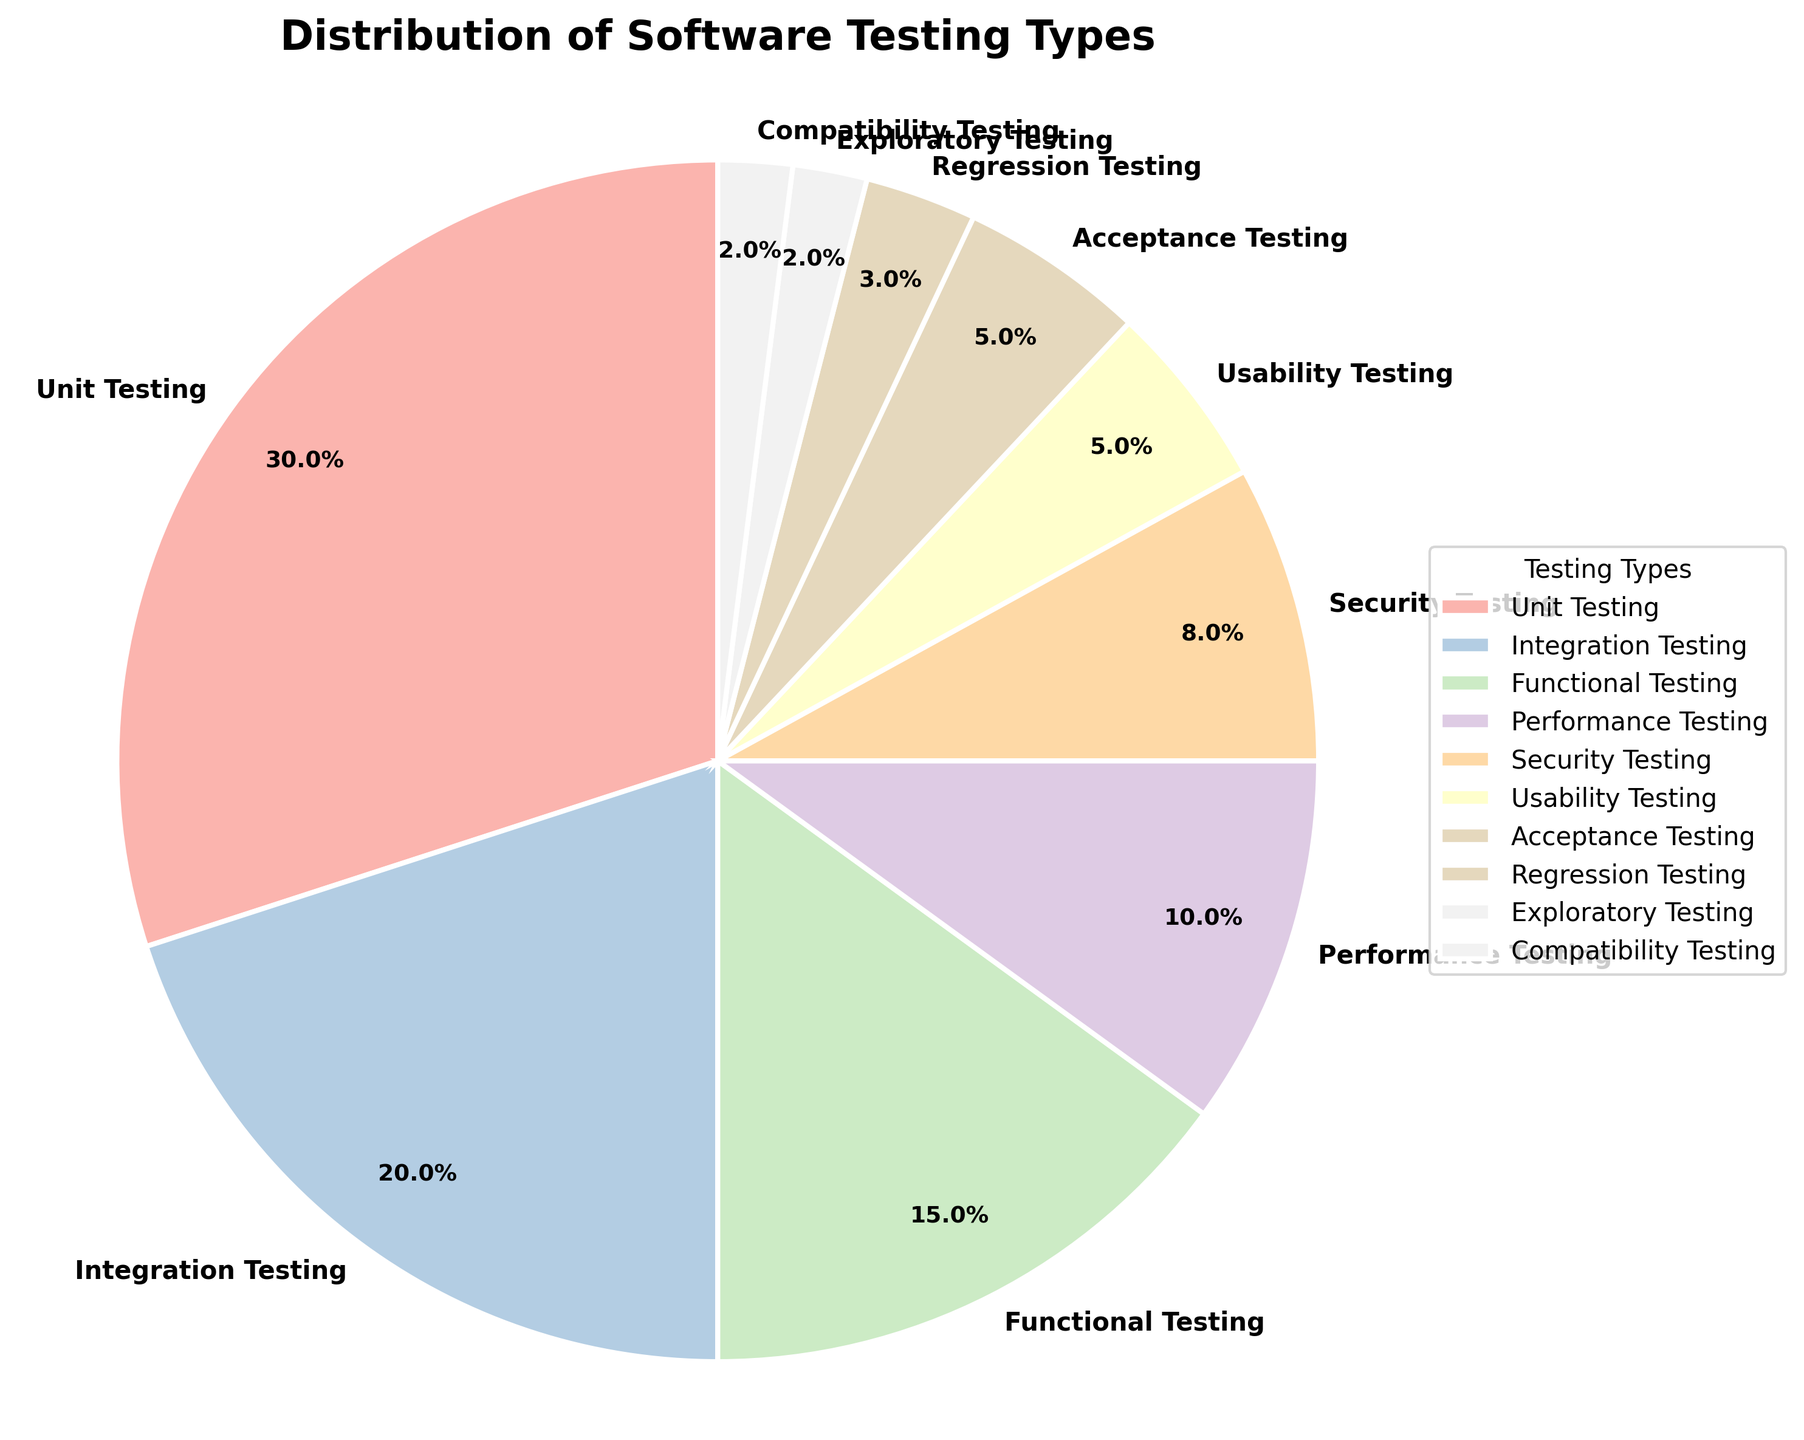What percentage of the total testing types is covered by Unit Testing and Integration Testing combined? Add the percentages for Unit Testing (30%) and Integration Testing (20%). 30 + 20 = 50
Answer: 50% Which testing type has a smaller percentage: Regression Testing or Exploratory Testing? Compare the percentages: Regression Testing (3%) and Exploratory Testing (2%). Regression Testing is larger than Exploratory Testing.
Answer: Exploratory Testing What is the difference in percentage between Performance Testing and Security Testing? Subtract the percentage of Security Testing (8%) from Performance Testing (10%). 10 - 8 = 2
Answer: 2% How many testing types have a percentage of 5%? Identify types with a 5% share: Usability Testing and Acceptance Testing. There are 2 such types.
Answer: 2 Which testing type occupies the largest segment in the pie chart? Look for the testing type with the highest percentage. Unit Testing has the largest percentage (30%).
Answer: Unit Testing What is the combined percentage of Security Testing, Usability Testing, and Acceptance Testing? Add their percentages: Security Testing (8%) + Usability Testing (5%) + Acceptance Testing (5%). 8 + 5 + 5 = 18.
Answer: 18% Which segment is represented by the second largest portion of the pie chart? The second-largest percentage is Integration Testing (20%).
Answer: Integration Testing List the testing types that have less than 5% share in the pie chart. Identify the types with less than 5%: Regression Testing (3%), Exploratory Testing (2%), and Compatibility Testing (2%).
Answer: Regression Testing, Exploratory Testing, Compatibility Testing If the sum of percentage for Unit Testing, Integration Testing, and Functional Testing combined is considered, what fractional part of the total 100% will it be? Add their percentages: Unit Testing (30%) + Integration Testing (20%) + Functional Testing (15%). 30 + 20 + 15 = 65%. The fraction is 65/100 = 13/20.
Answer: 13/20 Which testing type has exactly half the percentage of Integration Testing? Calculate half of Integration Testing (20%). 20 / 2 = 10%. Performance Testing is exactly 10%.
Answer: Performance Testing 